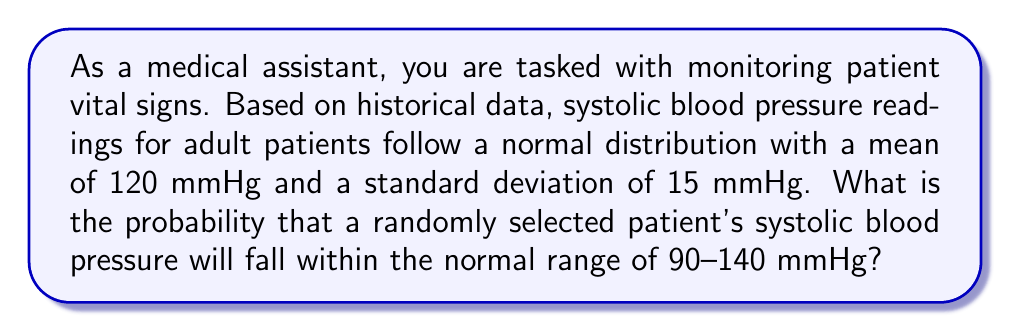Can you answer this question? Let's approach this step-by-step:

1) We are dealing with a normal distribution where:
   $\mu = 120$ mmHg (mean)
   $\sigma = 15$ mmHg (standard deviation)

2) We need to find the probability that a reading falls between 90 and 140 mmHg.

3) To use the standard normal distribution, we need to convert these values to z-scores:

   For 90 mmHg: $z_1 = \frac{90 - 120}{15} = -2$
   For 140 mmHg: $z_2 = \frac{140 - 120}{15} = \frac{20}{15} \approx 1.33$

4) Now, we need to find $P(-2 < Z < 1.33)$, where Z is the standard normal variable.

5) This can be rewritten as $P(Z < 1.33) - P(Z < -2)$

6) Using a standard normal distribution table or calculator:
   $P(Z < 1.33) \approx 0.9082$
   $P(Z < -2) \approx 0.0228$

7) Therefore, the probability is:
   $P(-2 < Z < 1.33) = 0.9082 - 0.0228 = 0.8854$

8) Converting to a percentage: $0.8854 \times 100\% = 88.54\%$
Answer: 88.54% 